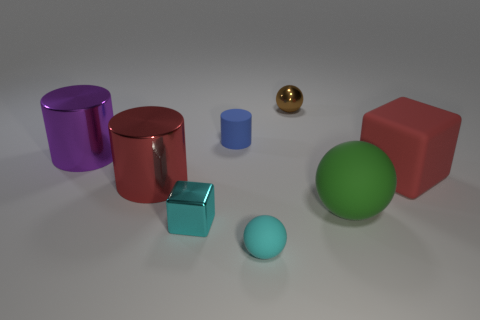Subtract all rubber spheres. How many spheres are left? 1 Add 1 brown balls. How many objects exist? 9 Subtract 1 balls. How many balls are left? 2 Subtract all cylinders. How many objects are left? 5 Subtract all blue cylinders. How many cylinders are left? 2 Subtract all purple blocks. Subtract all blue cylinders. How many blocks are left? 2 Subtract all tiny red things. Subtract all big metal things. How many objects are left? 6 Add 8 large balls. How many large balls are left? 9 Add 8 small cylinders. How many small cylinders exist? 9 Subtract 0 yellow spheres. How many objects are left? 8 